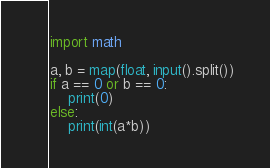<code> <loc_0><loc_0><loc_500><loc_500><_Python_>import math

a, b = map(float, input().split())
if a == 0 or b == 0:
    print(0)
else:
    print(int(a*b))
</code> 